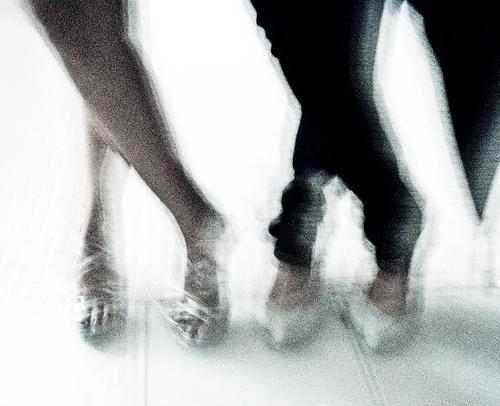What type of shoes are there?
Concise answer only. Heels. Are the legs crossed?
Short answer required. Yes. Is this photo in focus?
Quick response, please. No. 